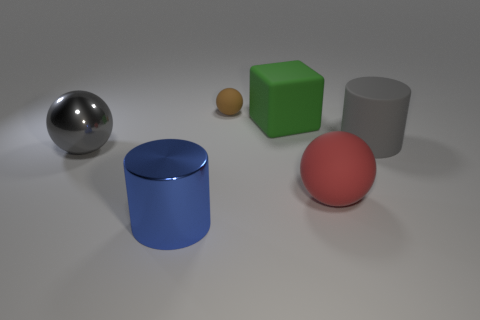Add 3 tiny cyan things. How many objects exist? 9 Subtract all cylinders. How many objects are left? 4 Subtract all red objects. Subtract all large red cubes. How many objects are left? 5 Add 4 gray matte objects. How many gray matte objects are left? 5 Add 4 yellow rubber cylinders. How many yellow rubber cylinders exist? 4 Subtract 0 green cylinders. How many objects are left? 6 